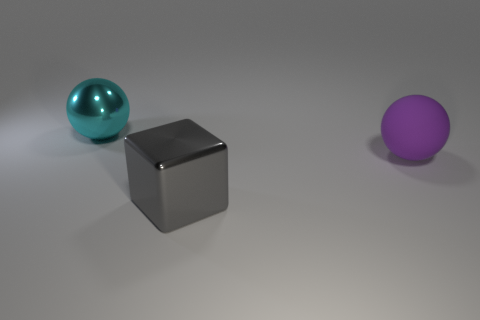Add 2 big cyan rubber things. How many objects exist? 5 Subtract all purple spheres. How many spheres are left? 1 Subtract 1 blocks. How many blocks are left? 0 Add 3 cyan spheres. How many cyan spheres exist? 4 Subtract 0 yellow cubes. How many objects are left? 3 Subtract all spheres. How many objects are left? 1 Subtract all cyan balls. Subtract all gray blocks. How many balls are left? 1 Subtract all gray blocks. How many cyan balls are left? 1 Subtract all big cyan metal spheres. Subtract all gray metallic objects. How many objects are left? 1 Add 1 gray metal things. How many gray metal things are left? 2 